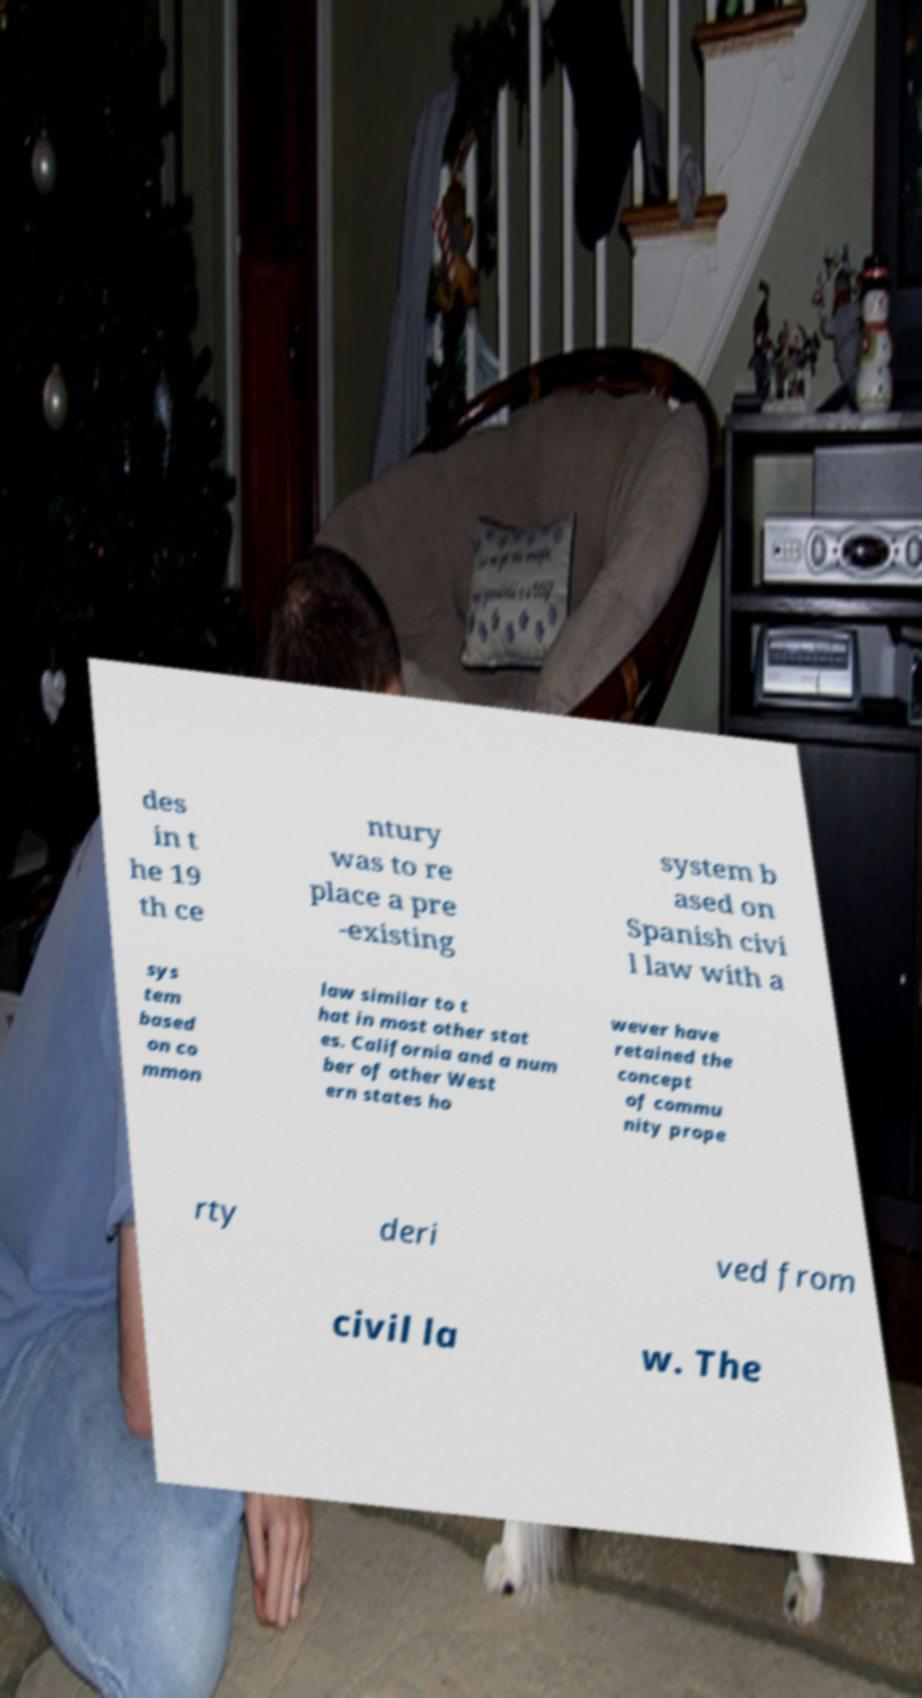There's text embedded in this image that I need extracted. Can you transcribe it verbatim? des in t he 19 th ce ntury was to re place a pre -existing system b ased on Spanish civi l law with a sys tem based on co mmon law similar to t hat in most other stat es. California and a num ber of other West ern states ho wever have retained the concept of commu nity prope rty deri ved from civil la w. The 